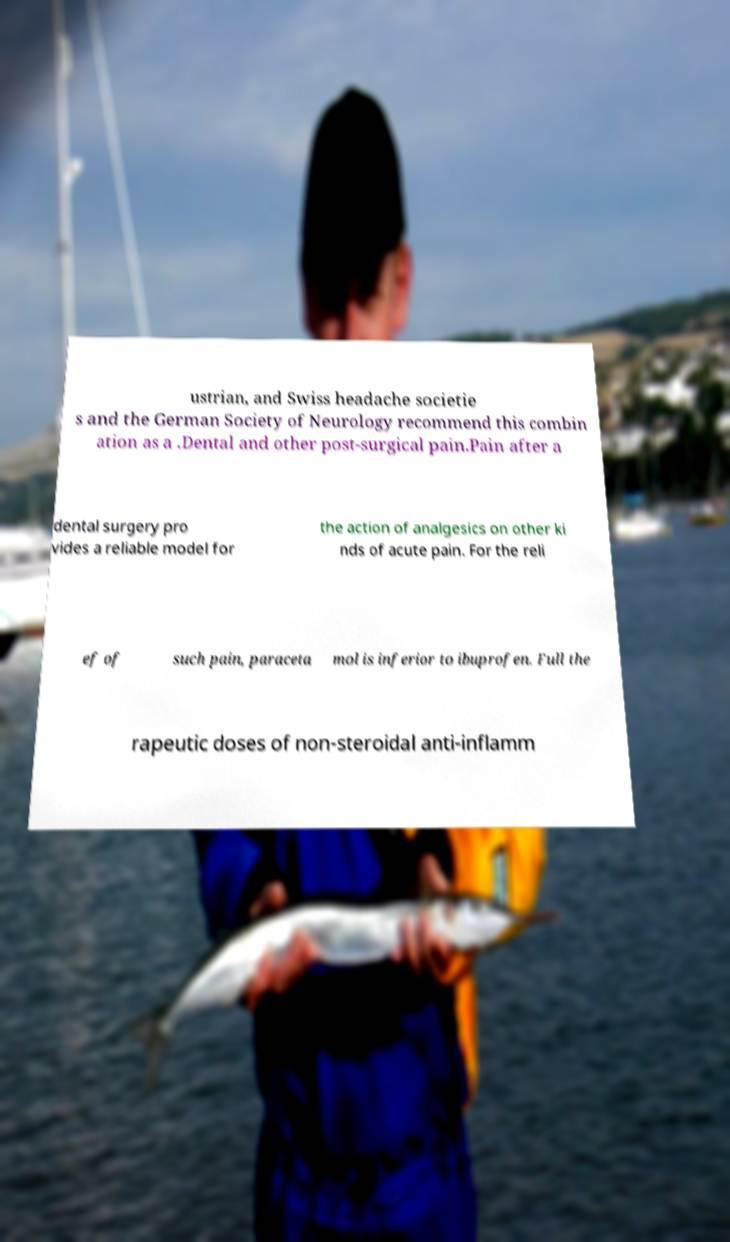Could you extract and type out the text from this image? ustrian, and Swiss headache societie s and the German Society of Neurology recommend this combin ation as a .Dental and other post-surgical pain.Pain after a dental surgery pro vides a reliable model for the action of analgesics on other ki nds of acute pain. For the reli ef of such pain, paraceta mol is inferior to ibuprofen. Full the rapeutic doses of non-steroidal anti-inflamm 